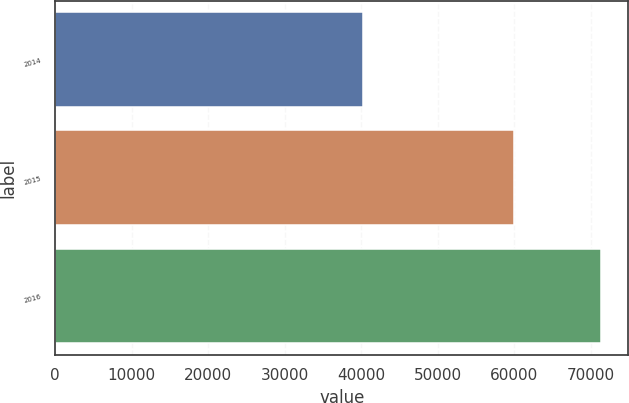Convert chart. <chart><loc_0><loc_0><loc_500><loc_500><bar_chart><fcel>2014<fcel>2015<fcel>2016<nl><fcel>40182<fcel>60009<fcel>71359<nl></chart> 